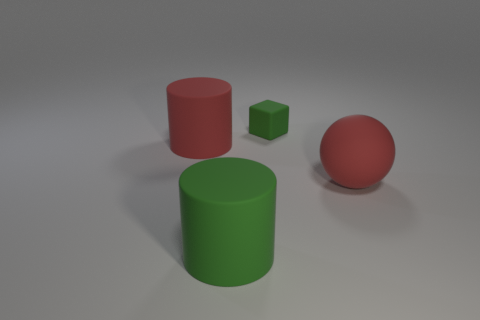What number of red balls are the same material as the large green cylinder?
Your response must be concise. 1. Are there fewer small purple metal things than big red rubber cylinders?
Give a very brief answer. Yes. There is a red matte object that is the same shape as the large green matte thing; what is its size?
Offer a very short reply. Large. Do the large thing that is in front of the matte ball and the big red cylinder have the same material?
Your response must be concise. Yes. Is the tiny rubber thing the same shape as the large green rubber thing?
Offer a very short reply. No. How many things are either green rubber objects to the left of the small green thing or large blue spheres?
Offer a very short reply. 1. There is a ball that is made of the same material as the tiny object; what is its size?
Provide a succinct answer. Large. How many large rubber objects are the same color as the large matte ball?
Make the answer very short. 1. What number of large things are green cubes or rubber objects?
Give a very brief answer. 3. There is a matte object that is the same color as the cube; what size is it?
Give a very brief answer. Large. 